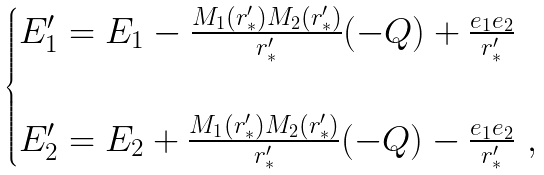<formula> <loc_0><loc_0><loc_500><loc_500>\begin{cases} E _ { 1 } ^ { \prime } = E _ { 1 } - \frac { M _ { 1 } ( r _ { * } ^ { \prime } ) M _ { 2 } ( r _ { * } ^ { \prime } ) } { r _ { * } ^ { \prime } } ( - Q ) + \frac { e _ { 1 } e _ { 2 } } { r _ { * } ^ { \prime } } \\ \\ E _ { 2 } ^ { \prime } = E _ { 2 } + \frac { M _ { 1 } ( r _ { * } ^ { \prime } ) M _ { 2 } ( r _ { * } ^ { \prime } ) } { r _ { * } ^ { \prime } } ( - Q ) - \frac { e _ { 1 } e _ { 2 } } { r _ { * } ^ { \prime } } \ , \end{cases}</formula> 